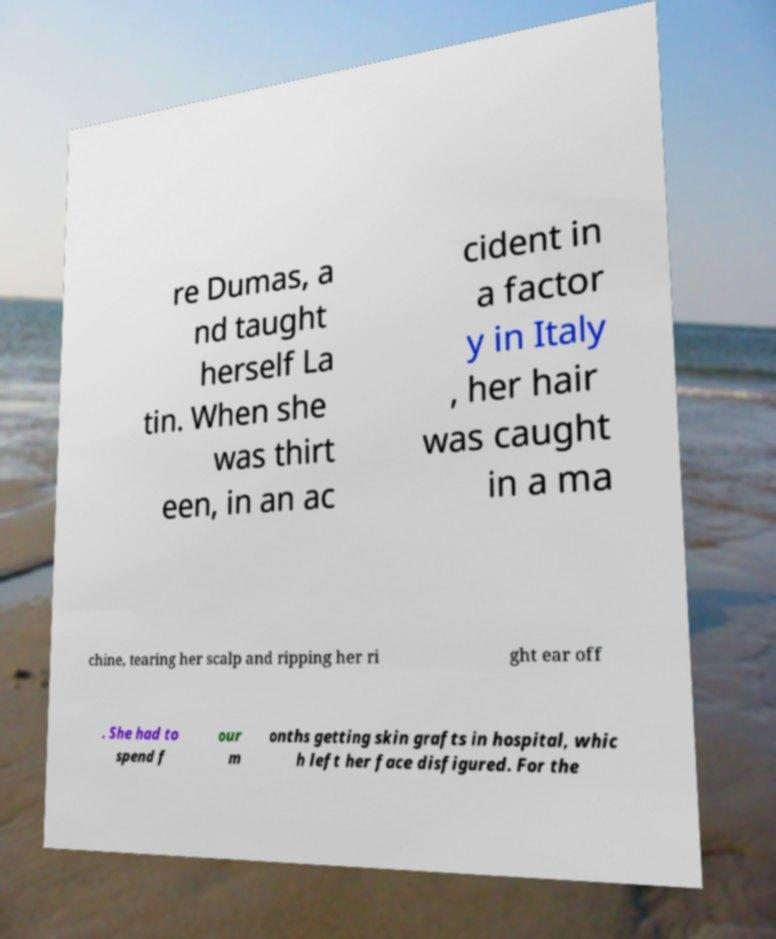What messages or text are displayed in this image? I need them in a readable, typed format. re Dumas, a nd taught herself La tin. When she was thirt een, in an ac cident in a factor y in Italy , her hair was caught in a ma chine, tearing her scalp and ripping her ri ght ear off . She had to spend f our m onths getting skin grafts in hospital, whic h left her face disfigured. For the 